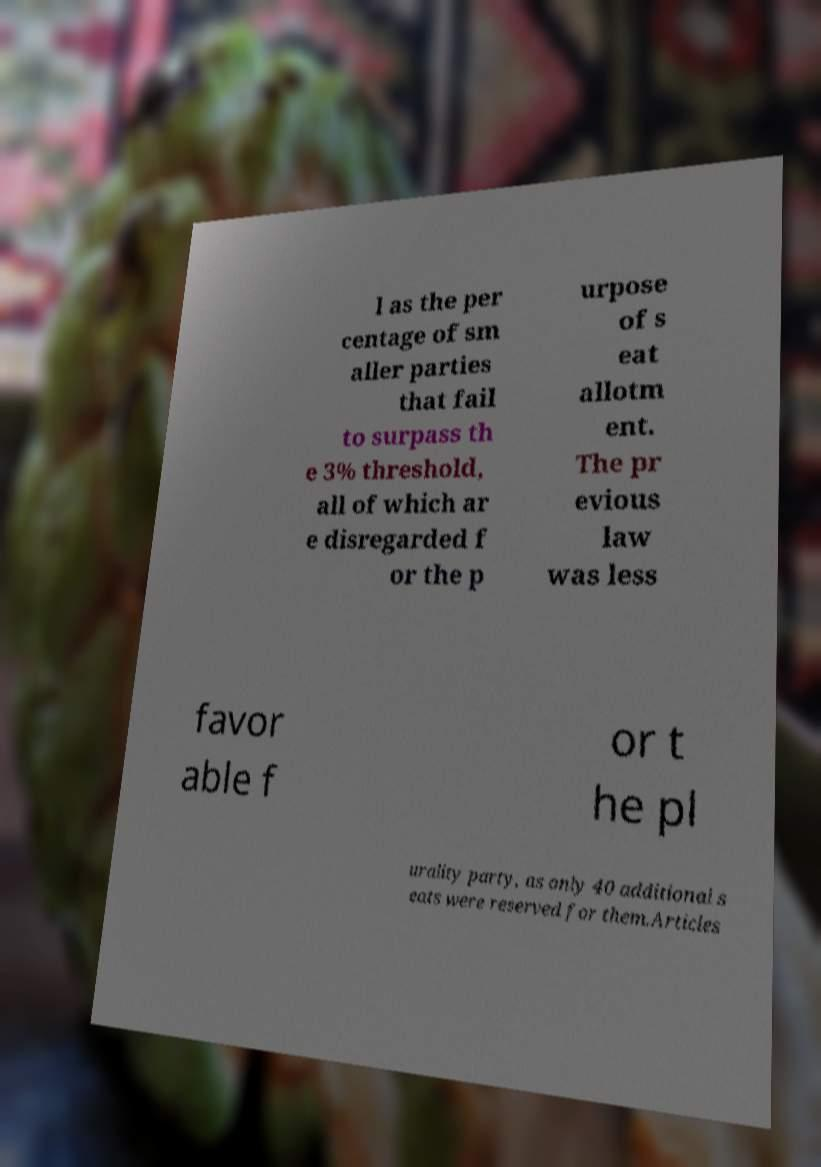Could you extract and type out the text from this image? l as the per centage of sm aller parties that fail to surpass th e 3% threshold, all of which ar e disregarded f or the p urpose of s eat allotm ent. The pr evious law was less favor able f or t he pl urality party, as only 40 additional s eats were reserved for them.Articles 